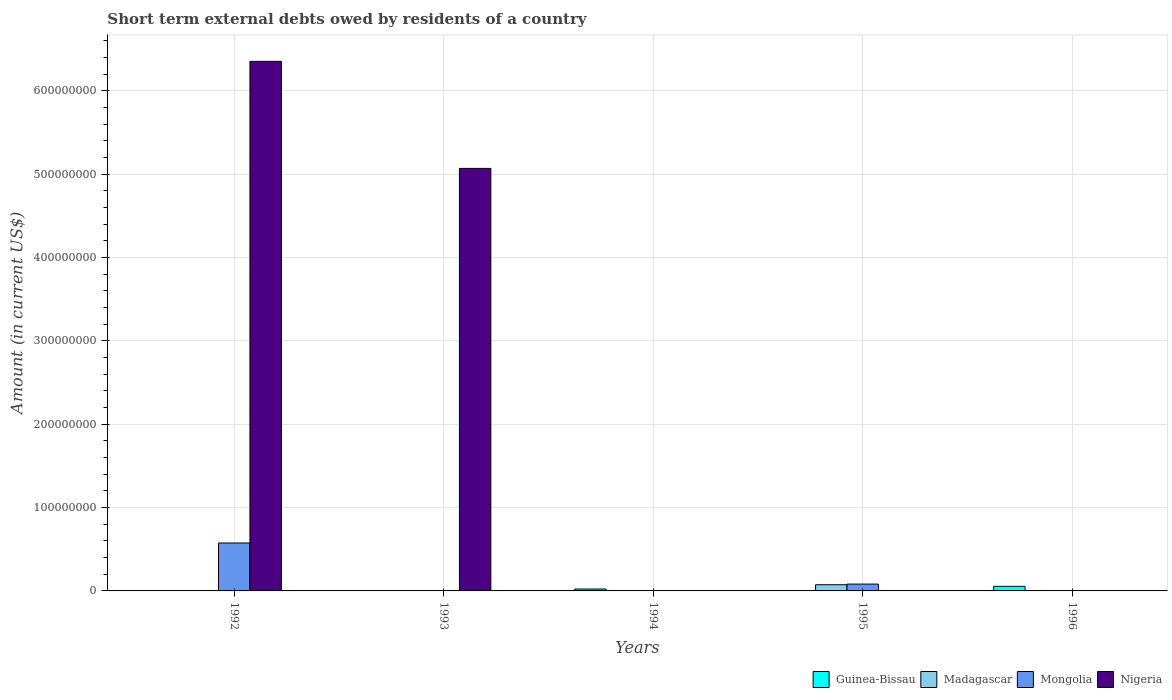How many different coloured bars are there?
Your answer should be compact. 4. How many bars are there on the 1st tick from the left?
Offer a very short reply. 2. How many bars are there on the 5th tick from the right?
Give a very brief answer. 2. In how many cases, is the number of bars for a given year not equal to the number of legend labels?
Your answer should be very brief. 5. Across all years, what is the maximum amount of short-term external debts owed by residents in Madagascar?
Make the answer very short. 7.42e+06. In which year was the amount of short-term external debts owed by residents in Mongolia maximum?
Provide a short and direct response. 1992. What is the total amount of short-term external debts owed by residents in Guinea-Bissau in the graph?
Provide a short and direct response. 7.77e+06. What is the difference between the amount of short-term external debts owed by residents in Nigeria in 1993 and the amount of short-term external debts owed by residents in Madagascar in 1994?
Ensure brevity in your answer.  5.07e+08. What is the average amount of short-term external debts owed by residents in Madagascar per year?
Provide a succinct answer. 1.48e+06. In the year 1995, what is the difference between the amount of short-term external debts owed by residents in Mongolia and amount of short-term external debts owed by residents in Madagascar?
Your answer should be compact. 7.70e+05. In how many years, is the amount of short-term external debts owed by residents in Mongolia greater than 300000000 US$?
Give a very brief answer. 0. What is the difference between the highest and the lowest amount of short-term external debts owed by residents in Madagascar?
Ensure brevity in your answer.  7.42e+06. In how many years, is the amount of short-term external debts owed by residents in Mongolia greater than the average amount of short-term external debts owed by residents in Mongolia taken over all years?
Your answer should be compact. 1. Is the sum of the amount of short-term external debts owed by residents in Nigeria in 1992 and 1993 greater than the maximum amount of short-term external debts owed by residents in Mongolia across all years?
Provide a succinct answer. Yes. Is it the case that in every year, the sum of the amount of short-term external debts owed by residents in Mongolia and amount of short-term external debts owed by residents in Madagascar is greater than the sum of amount of short-term external debts owed by residents in Guinea-Bissau and amount of short-term external debts owed by residents in Nigeria?
Ensure brevity in your answer.  No. Is it the case that in every year, the sum of the amount of short-term external debts owed by residents in Madagascar and amount of short-term external debts owed by residents in Guinea-Bissau is greater than the amount of short-term external debts owed by residents in Mongolia?
Your answer should be compact. No. Are all the bars in the graph horizontal?
Provide a succinct answer. No. How many years are there in the graph?
Your response must be concise. 5. What is the difference between two consecutive major ticks on the Y-axis?
Offer a very short reply. 1.00e+08. Are the values on the major ticks of Y-axis written in scientific E-notation?
Your answer should be compact. No. Does the graph contain any zero values?
Offer a very short reply. Yes. How many legend labels are there?
Your answer should be compact. 4. How are the legend labels stacked?
Offer a very short reply. Horizontal. What is the title of the graph?
Your answer should be compact. Short term external debts owed by residents of a country. Does "Mongolia" appear as one of the legend labels in the graph?
Provide a succinct answer. Yes. What is the label or title of the X-axis?
Provide a succinct answer. Years. What is the label or title of the Y-axis?
Your answer should be compact. Amount (in current US$). What is the Amount (in current US$) in Mongolia in 1992?
Your response must be concise. 5.75e+07. What is the Amount (in current US$) in Nigeria in 1992?
Provide a short and direct response. 6.35e+08. What is the Amount (in current US$) in Madagascar in 1993?
Offer a very short reply. 0. What is the Amount (in current US$) in Nigeria in 1993?
Your answer should be compact. 5.07e+08. What is the Amount (in current US$) of Guinea-Bissau in 1994?
Provide a succinct answer. 2.27e+06. What is the Amount (in current US$) of Madagascar in 1994?
Offer a very short reply. 0. What is the Amount (in current US$) in Mongolia in 1994?
Your answer should be very brief. 0. What is the Amount (in current US$) in Nigeria in 1994?
Make the answer very short. 0. What is the Amount (in current US$) in Guinea-Bissau in 1995?
Offer a very short reply. 0. What is the Amount (in current US$) of Madagascar in 1995?
Provide a succinct answer. 7.42e+06. What is the Amount (in current US$) of Mongolia in 1995?
Give a very brief answer. 8.19e+06. What is the Amount (in current US$) of Guinea-Bissau in 1996?
Make the answer very short. 5.50e+06. What is the Amount (in current US$) of Mongolia in 1996?
Provide a short and direct response. 0. What is the Amount (in current US$) in Nigeria in 1996?
Your answer should be very brief. 0. Across all years, what is the maximum Amount (in current US$) in Guinea-Bissau?
Offer a terse response. 5.50e+06. Across all years, what is the maximum Amount (in current US$) in Madagascar?
Offer a terse response. 7.42e+06. Across all years, what is the maximum Amount (in current US$) in Mongolia?
Your answer should be very brief. 5.75e+07. Across all years, what is the maximum Amount (in current US$) in Nigeria?
Provide a succinct answer. 6.35e+08. Across all years, what is the minimum Amount (in current US$) in Guinea-Bissau?
Provide a succinct answer. 0. Across all years, what is the minimum Amount (in current US$) in Nigeria?
Provide a short and direct response. 0. What is the total Amount (in current US$) of Guinea-Bissau in the graph?
Your answer should be very brief. 7.77e+06. What is the total Amount (in current US$) of Madagascar in the graph?
Offer a very short reply. 7.42e+06. What is the total Amount (in current US$) of Mongolia in the graph?
Ensure brevity in your answer.  6.57e+07. What is the total Amount (in current US$) in Nigeria in the graph?
Provide a succinct answer. 1.14e+09. What is the difference between the Amount (in current US$) of Nigeria in 1992 and that in 1993?
Give a very brief answer. 1.28e+08. What is the difference between the Amount (in current US$) of Mongolia in 1992 and that in 1995?
Keep it short and to the point. 4.93e+07. What is the difference between the Amount (in current US$) in Guinea-Bissau in 1994 and that in 1996?
Make the answer very short. -3.23e+06. What is the difference between the Amount (in current US$) in Mongolia in 1992 and the Amount (in current US$) in Nigeria in 1993?
Your answer should be compact. -4.49e+08. What is the difference between the Amount (in current US$) in Guinea-Bissau in 1994 and the Amount (in current US$) in Madagascar in 1995?
Offer a very short reply. -5.15e+06. What is the difference between the Amount (in current US$) of Guinea-Bissau in 1994 and the Amount (in current US$) of Mongolia in 1995?
Give a very brief answer. -5.92e+06. What is the average Amount (in current US$) in Guinea-Bissau per year?
Provide a short and direct response. 1.55e+06. What is the average Amount (in current US$) of Madagascar per year?
Offer a very short reply. 1.48e+06. What is the average Amount (in current US$) of Mongolia per year?
Offer a terse response. 1.31e+07. What is the average Amount (in current US$) of Nigeria per year?
Provide a short and direct response. 2.28e+08. In the year 1992, what is the difference between the Amount (in current US$) of Mongolia and Amount (in current US$) of Nigeria?
Your response must be concise. -5.78e+08. In the year 1995, what is the difference between the Amount (in current US$) in Madagascar and Amount (in current US$) in Mongolia?
Provide a succinct answer. -7.70e+05. What is the ratio of the Amount (in current US$) of Nigeria in 1992 to that in 1993?
Offer a very short reply. 1.25. What is the ratio of the Amount (in current US$) in Mongolia in 1992 to that in 1995?
Your answer should be very brief. 7.02. What is the ratio of the Amount (in current US$) of Guinea-Bissau in 1994 to that in 1996?
Keep it short and to the point. 0.41. What is the difference between the highest and the lowest Amount (in current US$) of Guinea-Bissau?
Your response must be concise. 5.50e+06. What is the difference between the highest and the lowest Amount (in current US$) of Madagascar?
Your answer should be very brief. 7.42e+06. What is the difference between the highest and the lowest Amount (in current US$) of Mongolia?
Provide a succinct answer. 5.75e+07. What is the difference between the highest and the lowest Amount (in current US$) of Nigeria?
Give a very brief answer. 6.35e+08. 